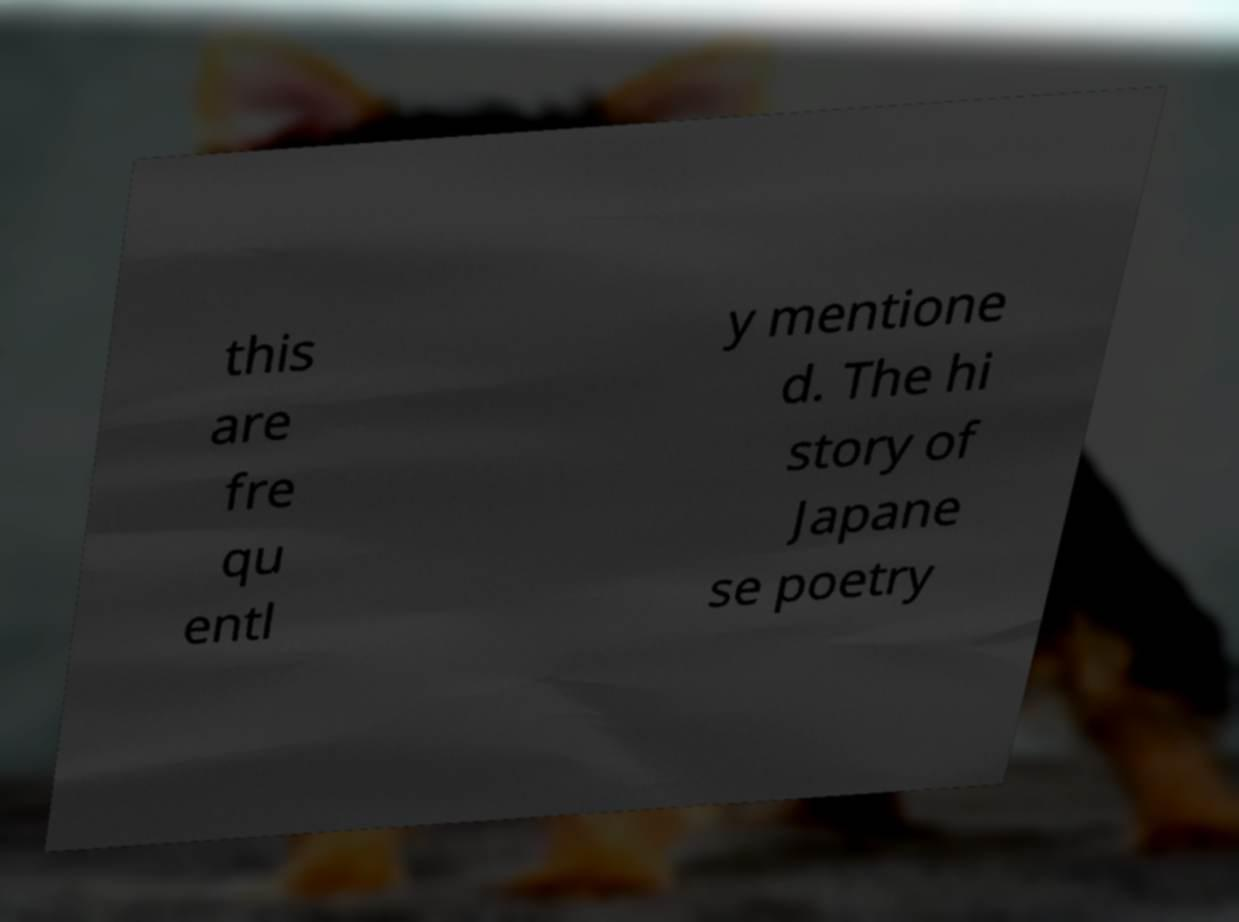There's text embedded in this image that I need extracted. Can you transcribe it verbatim? this are fre qu entl y mentione d. The hi story of Japane se poetry 